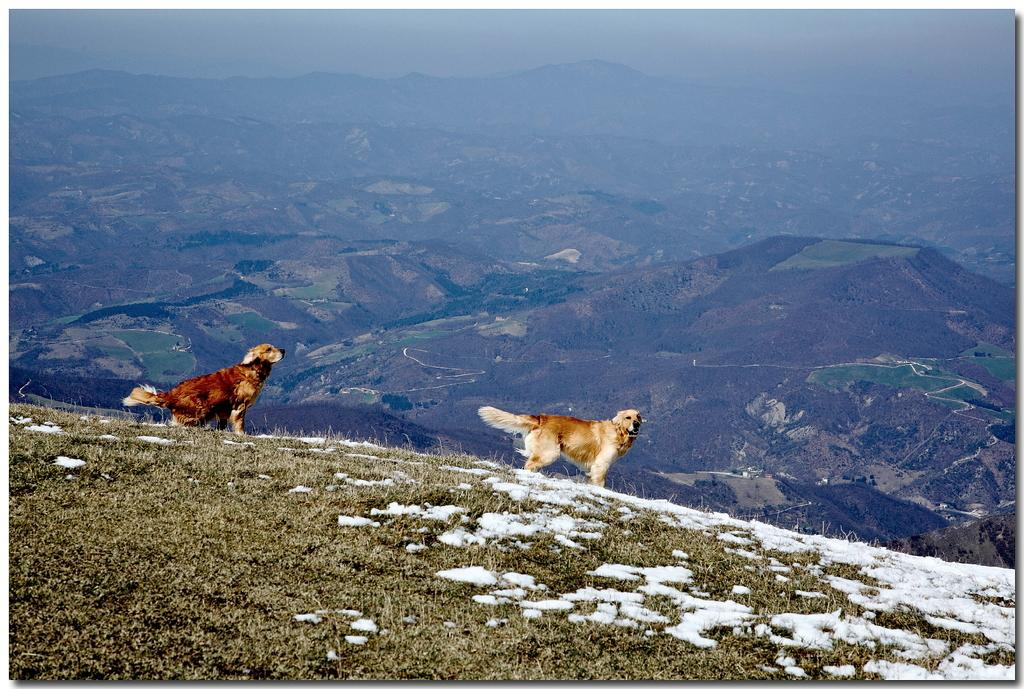What type of animals can be seen in the image? There are dogs in the image. What is the ground surface like in the image? There is grass on the ground in the image. What weather condition is depicted in the image? There is snow visible in the image. What can be seen in the distance in the image? There are mountains in the background of the image. What is visible above the mountains in the image? The sky is visible in the background of the image. Can you see the dogs' knees in the image? The image does not show the dogs' knees; it only shows their bodies and heads. 